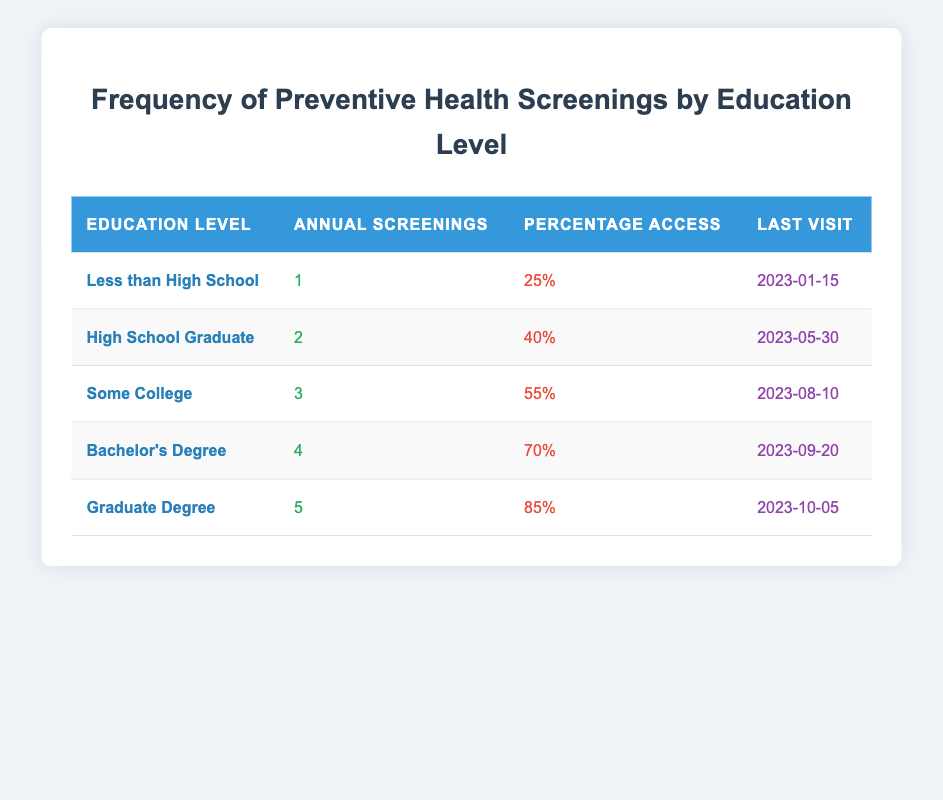What is the percentage access for women with a Bachelor's Degree? According to the table, the percentage access for women with a Bachelor's Degree is directly provided in the row corresponding to that education level. It shows a value of 70%.
Answer: 70% How many annual screenings do women with a Graduate Degree have? The table lists the number of annual screenings for women with a Graduate Degree. Directly from the row for this education level, the value is 5.
Answer: 5 True or False: Women with "Less than High School" education level have the highest percentage access. The percentage access for women with "Less than High School" is 25%. The highest percentage access in the table is for those with a Graduate Degree, which has 85%. Therefore, this statement is false.
Answer: False What is the difference in annual screenings between women with a High School Graduate and a Bachelor’s Degree? The table shows that women with a High School Graduate receive 2 annual screenings while those with a Bachelor’s Degree receive 4. The difference is calculated as 4 - 2 = 2.
Answer: 2 What is the average percentage access for all education levels? To find the average percentage access, sum the % access for each education level: 25 + 40 + 55 + 70 + 85 = 275. There are 5 education levels, so the average is 275 / 5 = 55.
Answer: 55 How many annual screenings does an individual with "Some College" education level have compared to an individual with "High School Graduate"? The number of annual screenings for "Some College" is 3 and for "High School Graduate" is 2. To compare: 3 (Some College) vs. 2 (High School Graduate) shows that those with Some College have 1 more annual screening than those with High School Graduate.
Answer: 1 more Which education level has the most recent last visit date? The table shows the last visit dates for each education level. The latest date is for those with a Graduate Degree, which is 2023-10-05, indicating they had the most recent last visit.
Answer: Graduate Degree What is the total number of annual screenings for all education levels combined? To find the total number of annual screenings, you sum the individual values: 1 + 2 + 3 + 4 + 5 = 15.
Answer: 15 